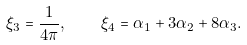<formula> <loc_0><loc_0><loc_500><loc_500>\xi _ { 3 } = \frac { 1 } { 4 \pi } , \quad \xi _ { 4 } = \alpha _ { 1 } + 3 \alpha _ { 2 } + 8 \alpha _ { 3 } .</formula> 